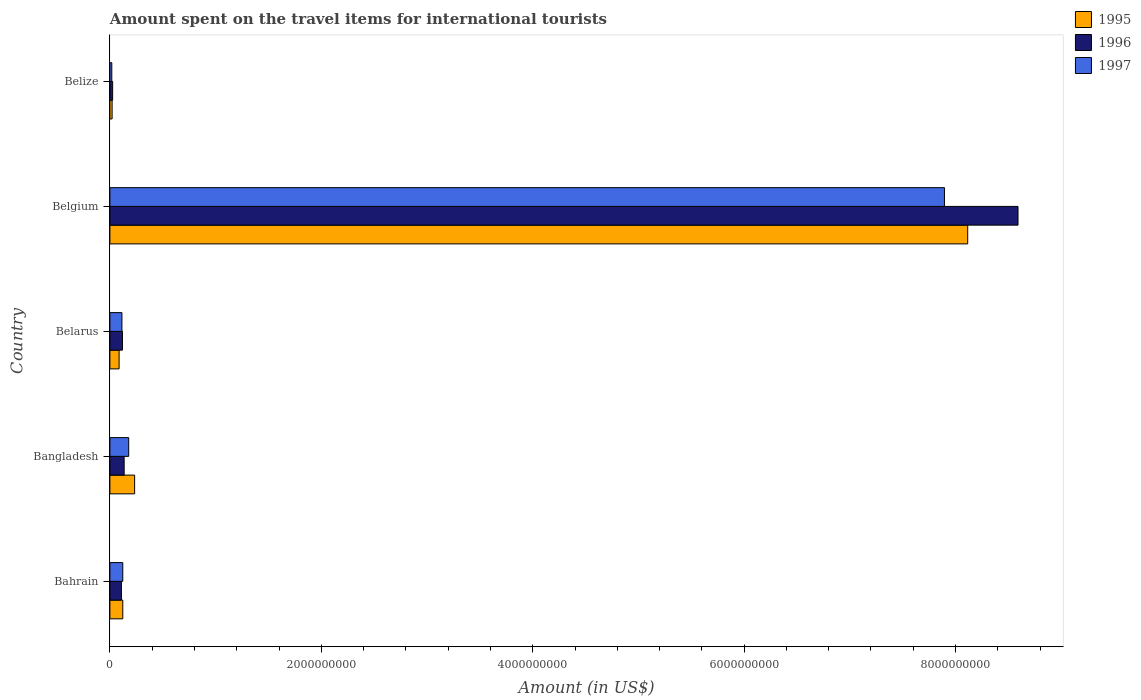How many different coloured bars are there?
Your answer should be very brief. 3. How many groups of bars are there?
Offer a terse response. 5. How many bars are there on the 4th tick from the bottom?
Make the answer very short. 3. What is the label of the 1st group of bars from the top?
Provide a succinct answer. Belize. In how many cases, is the number of bars for a given country not equal to the number of legend labels?
Ensure brevity in your answer.  0. What is the amount spent on the travel items for international tourists in 1995 in Belgium?
Offer a very short reply. 8.12e+09. Across all countries, what is the maximum amount spent on the travel items for international tourists in 1996?
Provide a succinct answer. 8.59e+09. Across all countries, what is the minimum amount spent on the travel items for international tourists in 1996?
Your response must be concise. 2.60e+07. In which country was the amount spent on the travel items for international tourists in 1995 maximum?
Keep it short and to the point. Belgium. In which country was the amount spent on the travel items for international tourists in 1997 minimum?
Provide a short and direct response. Belize. What is the total amount spent on the travel items for international tourists in 1996 in the graph?
Offer a very short reply. 8.98e+09. What is the difference between the amount spent on the travel items for international tourists in 1997 in Bahrain and that in Belize?
Ensure brevity in your answer.  1.04e+08. What is the difference between the amount spent on the travel items for international tourists in 1995 in Bahrain and the amount spent on the travel items for international tourists in 1996 in Belgium?
Give a very brief answer. -8.47e+09. What is the average amount spent on the travel items for international tourists in 1997 per country?
Provide a short and direct response. 1.67e+09. In how many countries, is the amount spent on the travel items for international tourists in 1996 greater than 1600000000 US$?
Your response must be concise. 1. What is the ratio of the amount spent on the travel items for international tourists in 1996 in Belarus to that in Belgium?
Provide a succinct answer. 0.01. Is the amount spent on the travel items for international tourists in 1997 in Bahrain less than that in Belgium?
Provide a short and direct response. Yes. What is the difference between the highest and the second highest amount spent on the travel items for international tourists in 1995?
Make the answer very short. 7.88e+09. What is the difference between the highest and the lowest amount spent on the travel items for international tourists in 1996?
Make the answer very short. 8.56e+09. What does the 2nd bar from the bottom in Belgium represents?
Give a very brief answer. 1996. What is the difference between two consecutive major ticks on the X-axis?
Your response must be concise. 2.00e+09. Are the values on the major ticks of X-axis written in scientific E-notation?
Your answer should be compact. No. Does the graph contain grids?
Keep it short and to the point. No. How are the legend labels stacked?
Offer a very short reply. Vertical. What is the title of the graph?
Offer a terse response. Amount spent on the travel items for international tourists. What is the label or title of the X-axis?
Make the answer very short. Amount (in US$). What is the label or title of the Y-axis?
Provide a short and direct response. Country. What is the Amount (in US$) of 1995 in Bahrain?
Offer a terse response. 1.22e+08. What is the Amount (in US$) in 1996 in Bahrain?
Ensure brevity in your answer.  1.09e+08. What is the Amount (in US$) of 1997 in Bahrain?
Provide a succinct answer. 1.22e+08. What is the Amount (in US$) in 1995 in Bangladesh?
Your response must be concise. 2.34e+08. What is the Amount (in US$) in 1996 in Bangladesh?
Offer a very short reply. 1.35e+08. What is the Amount (in US$) of 1997 in Bangladesh?
Offer a terse response. 1.78e+08. What is the Amount (in US$) of 1995 in Belarus?
Give a very brief answer. 8.70e+07. What is the Amount (in US$) of 1996 in Belarus?
Ensure brevity in your answer.  1.19e+08. What is the Amount (in US$) of 1997 in Belarus?
Give a very brief answer. 1.14e+08. What is the Amount (in US$) of 1995 in Belgium?
Ensure brevity in your answer.  8.12e+09. What is the Amount (in US$) in 1996 in Belgium?
Offer a very short reply. 8.59e+09. What is the Amount (in US$) in 1997 in Belgium?
Make the answer very short. 7.90e+09. What is the Amount (in US$) in 1995 in Belize?
Offer a very short reply. 2.10e+07. What is the Amount (in US$) in 1996 in Belize?
Ensure brevity in your answer.  2.60e+07. What is the Amount (in US$) in 1997 in Belize?
Your answer should be compact. 1.80e+07. Across all countries, what is the maximum Amount (in US$) in 1995?
Your response must be concise. 8.12e+09. Across all countries, what is the maximum Amount (in US$) in 1996?
Provide a short and direct response. 8.59e+09. Across all countries, what is the maximum Amount (in US$) in 1997?
Your answer should be very brief. 7.90e+09. Across all countries, what is the minimum Amount (in US$) of 1995?
Offer a terse response. 2.10e+07. Across all countries, what is the minimum Amount (in US$) in 1996?
Ensure brevity in your answer.  2.60e+07. Across all countries, what is the minimum Amount (in US$) of 1997?
Keep it short and to the point. 1.80e+07. What is the total Amount (in US$) of 1995 in the graph?
Make the answer very short. 8.58e+09. What is the total Amount (in US$) in 1996 in the graph?
Your answer should be very brief. 8.98e+09. What is the total Amount (in US$) of 1997 in the graph?
Your answer should be very brief. 8.33e+09. What is the difference between the Amount (in US$) of 1995 in Bahrain and that in Bangladesh?
Your answer should be compact. -1.12e+08. What is the difference between the Amount (in US$) of 1996 in Bahrain and that in Bangladesh?
Give a very brief answer. -2.60e+07. What is the difference between the Amount (in US$) of 1997 in Bahrain and that in Bangladesh?
Offer a terse response. -5.60e+07. What is the difference between the Amount (in US$) of 1995 in Bahrain and that in Belarus?
Offer a very short reply. 3.50e+07. What is the difference between the Amount (in US$) of 1996 in Bahrain and that in Belarus?
Offer a terse response. -1.00e+07. What is the difference between the Amount (in US$) in 1997 in Bahrain and that in Belarus?
Keep it short and to the point. 8.00e+06. What is the difference between the Amount (in US$) of 1995 in Bahrain and that in Belgium?
Ensure brevity in your answer.  -7.99e+09. What is the difference between the Amount (in US$) of 1996 in Bahrain and that in Belgium?
Ensure brevity in your answer.  -8.48e+09. What is the difference between the Amount (in US$) in 1997 in Bahrain and that in Belgium?
Offer a very short reply. -7.77e+09. What is the difference between the Amount (in US$) of 1995 in Bahrain and that in Belize?
Ensure brevity in your answer.  1.01e+08. What is the difference between the Amount (in US$) in 1996 in Bahrain and that in Belize?
Make the answer very short. 8.30e+07. What is the difference between the Amount (in US$) in 1997 in Bahrain and that in Belize?
Keep it short and to the point. 1.04e+08. What is the difference between the Amount (in US$) of 1995 in Bangladesh and that in Belarus?
Your answer should be compact. 1.47e+08. What is the difference between the Amount (in US$) of 1996 in Bangladesh and that in Belarus?
Provide a succinct answer. 1.60e+07. What is the difference between the Amount (in US$) of 1997 in Bangladesh and that in Belarus?
Offer a terse response. 6.40e+07. What is the difference between the Amount (in US$) of 1995 in Bangladesh and that in Belgium?
Your answer should be very brief. -7.88e+09. What is the difference between the Amount (in US$) of 1996 in Bangladesh and that in Belgium?
Keep it short and to the point. -8.46e+09. What is the difference between the Amount (in US$) in 1997 in Bangladesh and that in Belgium?
Your answer should be very brief. -7.72e+09. What is the difference between the Amount (in US$) in 1995 in Bangladesh and that in Belize?
Offer a very short reply. 2.13e+08. What is the difference between the Amount (in US$) in 1996 in Bangladesh and that in Belize?
Offer a very short reply. 1.09e+08. What is the difference between the Amount (in US$) of 1997 in Bangladesh and that in Belize?
Keep it short and to the point. 1.60e+08. What is the difference between the Amount (in US$) of 1995 in Belarus and that in Belgium?
Make the answer very short. -8.03e+09. What is the difference between the Amount (in US$) in 1996 in Belarus and that in Belgium?
Your answer should be very brief. -8.47e+09. What is the difference between the Amount (in US$) in 1997 in Belarus and that in Belgium?
Your answer should be very brief. -7.78e+09. What is the difference between the Amount (in US$) of 1995 in Belarus and that in Belize?
Give a very brief answer. 6.60e+07. What is the difference between the Amount (in US$) in 1996 in Belarus and that in Belize?
Provide a short and direct response. 9.30e+07. What is the difference between the Amount (in US$) in 1997 in Belarus and that in Belize?
Your response must be concise. 9.60e+07. What is the difference between the Amount (in US$) of 1995 in Belgium and that in Belize?
Your answer should be compact. 8.09e+09. What is the difference between the Amount (in US$) in 1996 in Belgium and that in Belize?
Your answer should be compact. 8.56e+09. What is the difference between the Amount (in US$) of 1997 in Belgium and that in Belize?
Keep it short and to the point. 7.88e+09. What is the difference between the Amount (in US$) in 1995 in Bahrain and the Amount (in US$) in 1996 in Bangladesh?
Offer a very short reply. -1.30e+07. What is the difference between the Amount (in US$) of 1995 in Bahrain and the Amount (in US$) of 1997 in Bangladesh?
Offer a very short reply. -5.60e+07. What is the difference between the Amount (in US$) in 1996 in Bahrain and the Amount (in US$) in 1997 in Bangladesh?
Offer a terse response. -6.90e+07. What is the difference between the Amount (in US$) of 1996 in Bahrain and the Amount (in US$) of 1997 in Belarus?
Your response must be concise. -5.00e+06. What is the difference between the Amount (in US$) of 1995 in Bahrain and the Amount (in US$) of 1996 in Belgium?
Ensure brevity in your answer.  -8.47e+09. What is the difference between the Amount (in US$) in 1995 in Bahrain and the Amount (in US$) in 1997 in Belgium?
Your answer should be very brief. -7.77e+09. What is the difference between the Amount (in US$) in 1996 in Bahrain and the Amount (in US$) in 1997 in Belgium?
Make the answer very short. -7.79e+09. What is the difference between the Amount (in US$) of 1995 in Bahrain and the Amount (in US$) of 1996 in Belize?
Offer a terse response. 9.60e+07. What is the difference between the Amount (in US$) of 1995 in Bahrain and the Amount (in US$) of 1997 in Belize?
Your answer should be compact. 1.04e+08. What is the difference between the Amount (in US$) in 1996 in Bahrain and the Amount (in US$) in 1997 in Belize?
Give a very brief answer. 9.10e+07. What is the difference between the Amount (in US$) of 1995 in Bangladesh and the Amount (in US$) of 1996 in Belarus?
Give a very brief answer. 1.15e+08. What is the difference between the Amount (in US$) of 1995 in Bangladesh and the Amount (in US$) of 1997 in Belarus?
Make the answer very short. 1.20e+08. What is the difference between the Amount (in US$) in 1996 in Bangladesh and the Amount (in US$) in 1997 in Belarus?
Ensure brevity in your answer.  2.10e+07. What is the difference between the Amount (in US$) in 1995 in Bangladesh and the Amount (in US$) in 1996 in Belgium?
Provide a succinct answer. -8.36e+09. What is the difference between the Amount (in US$) of 1995 in Bangladesh and the Amount (in US$) of 1997 in Belgium?
Make the answer very short. -7.66e+09. What is the difference between the Amount (in US$) of 1996 in Bangladesh and the Amount (in US$) of 1997 in Belgium?
Your answer should be very brief. -7.76e+09. What is the difference between the Amount (in US$) in 1995 in Bangladesh and the Amount (in US$) in 1996 in Belize?
Your answer should be compact. 2.08e+08. What is the difference between the Amount (in US$) of 1995 in Bangladesh and the Amount (in US$) of 1997 in Belize?
Your response must be concise. 2.16e+08. What is the difference between the Amount (in US$) in 1996 in Bangladesh and the Amount (in US$) in 1997 in Belize?
Provide a short and direct response. 1.17e+08. What is the difference between the Amount (in US$) of 1995 in Belarus and the Amount (in US$) of 1996 in Belgium?
Keep it short and to the point. -8.50e+09. What is the difference between the Amount (in US$) of 1995 in Belarus and the Amount (in US$) of 1997 in Belgium?
Keep it short and to the point. -7.81e+09. What is the difference between the Amount (in US$) of 1996 in Belarus and the Amount (in US$) of 1997 in Belgium?
Provide a short and direct response. -7.78e+09. What is the difference between the Amount (in US$) in 1995 in Belarus and the Amount (in US$) in 1996 in Belize?
Provide a succinct answer. 6.10e+07. What is the difference between the Amount (in US$) of 1995 in Belarus and the Amount (in US$) of 1997 in Belize?
Provide a succinct answer. 6.90e+07. What is the difference between the Amount (in US$) of 1996 in Belarus and the Amount (in US$) of 1997 in Belize?
Ensure brevity in your answer.  1.01e+08. What is the difference between the Amount (in US$) of 1995 in Belgium and the Amount (in US$) of 1996 in Belize?
Offer a terse response. 8.09e+09. What is the difference between the Amount (in US$) of 1995 in Belgium and the Amount (in US$) of 1997 in Belize?
Your answer should be very brief. 8.10e+09. What is the difference between the Amount (in US$) in 1996 in Belgium and the Amount (in US$) in 1997 in Belize?
Make the answer very short. 8.57e+09. What is the average Amount (in US$) of 1995 per country?
Offer a very short reply. 1.72e+09. What is the average Amount (in US$) in 1996 per country?
Keep it short and to the point. 1.80e+09. What is the average Amount (in US$) of 1997 per country?
Your answer should be compact. 1.67e+09. What is the difference between the Amount (in US$) in 1995 and Amount (in US$) in 1996 in Bahrain?
Ensure brevity in your answer.  1.30e+07. What is the difference between the Amount (in US$) of 1995 and Amount (in US$) of 1997 in Bahrain?
Provide a short and direct response. 0. What is the difference between the Amount (in US$) in 1996 and Amount (in US$) in 1997 in Bahrain?
Provide a short and direct response. -1.30e+07. What is the difference between the Amount (in US$) of 1995 and Amount (in US$) of 1996 in Bangladesh?
Provide a succinct answer. 9.90e+07. What is the difference between the Amount (in US$) in 1995 and Amount (in US$) in 1997 in Bangladesh?
Make the answer very short. 5.60e+07. What is the difference between the Amount (in US$) in 1996 and Amount (in US$) in 1997 in Bangladesh?
Provide a short and direct response. -4.30e+07. What is the difference between the Amount (in US$) in 1995 and Amount (in US$) in 1996 in Belarus?
Offer a very short reply. -3.20e+07. What is the difference between the Amount (in US$) of 1995 and Amount (in US$) of 1997 in Belarus?
Provide a short and direct response. -2.70e+07. What is the difference between the Amount (in US$) of 1996 and Amount (in US$) of 1997 in Belarus?
Offer a very short reply. 5.00e+06. What is the difference between the Amount (in US$) in 1995 and Amount (in US$) in 1996 in Belgium?
Ensure brevity in your answer.  -4.76e+08. What is the difference between the Amount (in US$) of 1995 and Amount (in US$) of 1997 in Belgium?
Give a very brief answer. 2.20e+08. What is the difference between the Amount (in US$) in 1996 and Amount (in US$) in 1997 in Belgium?
Your response must be concise. 6.96e+08. What is the difference between the Amount (in US$) in 1995 and Amount (in US$) in 1996 in Belize?
Ensure brevity in your answer.  -5.00e+06. What is the ratio of the Amount (in US$) of 1995 in Bahrain to that in Bangladesh?
Make the answer very short. 0.52. What is the ratio of the Amount (in US$) in 1996 in Bahrain to that in Bangladesh?
Give a very brief answer. 0.81. What is the ratio of the Amount (in US$) in 1997 in Bahrain to that in Bangladesh?
Make the answer very short. 0.69. What is the ratio of the Amount (in US$) in 1995 in Bahrain to that in Belarus?
Give a very brief answer. 1.4. What is the ratio of the Amount (in US$) of 1996 in Bahrain to that in Belarus?
Provide a succinct answer. 0.92. What is the ratio of the Amount (in US$) of 1997 in Bahrain to that in Belarus?
Your answer should be very brief. 1.07. What is the ratio of the Amount (in US$) of 1995 in Bahrain to that in Belgium?
Provide a succinct answer. 0.01. What is the ratio of the Amount (in US$) of 1996 in Bahrain to that in Belgium?
Provide a short and direct response. 0.01. What is the ratio of the Amount (in US$) in 1997 in Bahrain to that in Belgium?
Your answer should be compact. 0.02. What is the ratio of the Amount (in US$) in 1995 in Bahrain to that in Belize?
Make the answer very short. 5.81. What is the ratio of the Amount (in US$) in 1996 in Bahrain to that in Belize?
Provide a succinct answer. 4.19. What is the ratio of the Amount (in US$) of 1997 in Bahrain to that in Belize?
Offer a terse response. 6.78. What is the ratio of the Amount (in US$) of 1995 in Bangladesh to that in Belarus?
Provide a short and direct response. 2.69. What is the ratio of the Amount (in US$) of 1996 in Bangladesh to that in Belarus?
Your answer should be very brief. 1.13. What is the ratio of the Amount (in US$) in 1997 in Bangladesh to that in Belarus?
Give a very brief answer. 1.56. What is the ratio of the Amount (in US$) of 1995 in Bangladesh to that in Belgium?
Provide a short and direct response. 0.03. What is the ratio of the Amount (in US$) of 1996 in Bangladesh to that in Belgium?
Ensure brevity in your answer.  0.02. What is the ratio of the Amount (in US$) in 1997 in Bangladesh to that in Belgium?
Make the answer very short. 0.02. What is the ratio of the Amount (in US$) of 1995 in Bangladesh to that in Belize?
Keep it short and to the point. 11.14. What is the ratio of the Amount (in US$) of 1996 in Bangladesh to that in Belize?
Give a very brief answer. 5.19. What is the ratio of the Amount (in US$) in 1997 in Bangladesh to that in Belize?
Your response must be concise. 9.89. What is the ratio of the Amount (in US$) of 1995 in Belarus to that in Belgium?
Provide a succinct answer. 0.01. What is the ratio of the Amount (in US$) of 1996 in Belarus to that in Belgium?
Provide a succinct answer. 0.01. What is the ratio of the Amount (in US$) in 1997 in Belarus to that in Belgium?
Provide a succinct answer. 0.01. What is the ratio of the Amount (in US$) of 1995 in Belarus to that in Belize?
Offer a very short reply. 4.14. What is the ratio of the Amount (in US$) in 1996 in Belarus to that in Belize?
Ensure brevity in your answer.  4.58. What is the ratio of the Amount (in US$) of 1997 in Belarus to that in Belize?
Keep it short and to the point. 6.33. What is the ratio of the Amount (in US$) in 1995 in Belgium to that in Belize?
Ensure brevity in your answer.  386.43. What is the ratio of the Amount (in US$) in 1996 in Belgium to that in Belize?
Make the answer very short. 330.42. What is the ratio of the Amount (in US$) of 1997 in Belgium to that in Belize?
Provide a short and direct response. 438.61. What is the difference between the highest and the second highest Amount (in US$) of 1995?
Keep it short and to the point. 7.88e+09. What is the difference between the highest and the second highest Amount (in US$) of 1996?
Your answer should be very brief. 8.46e+09. What is the difference between the highest and the second highest Amount (in US$) of 1997?
Your answer should be compact. 7.72e+09. What is the difference between the highest and the lowest Amount (in US$) of 1995?
Ensure brevity in your answer.  8.09e+09. What is the difference between the highest and the lowest Amount (in US$) of 1996?
Your answer should be very brief. 8.56e+09. What is the difference between the highest and the lowest Amount (in US$) of 1997?
Your answer should be compact. 7.88e+09. 